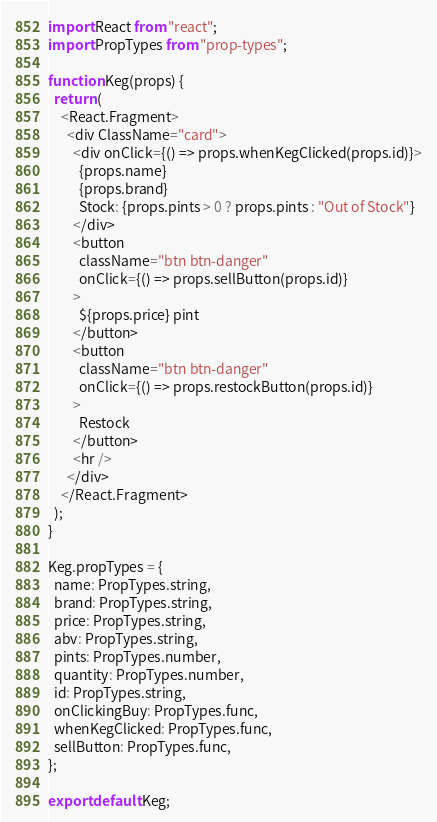Convert code to text. <code><loc_0><loc_0><loc_500><loc_500><_JavaScript_>import React from "react";
import PropTypes from "prop-types";

function Keg(props) {
  return (
    <React.Fragment>
      <div ClassName="card">
        <div onClick={() => props.whenKegClicked(props.id)}>
          {props.name}
          {props.brand}
          Stock: {props.pints > 0 ? props.pints : "Out of Stock"}
        </div>
        <button
          className="btn btn-danger"
          onClick={() => props.sellButton(props.id)}
        >
          ${props.price} pint
        </button>
        <button
          className="btn btn-danger"
          onClick={() => props.restockButton(props.id)}
        >
          Restock
        </button>
        <hr />
      </div>
    </React.Fragment>
  );
}

Keg.propTypes = {
  name: PropTypes.string,
  brand: PropTypes.string,
  price: PropTypes.string,
  abv: PropTypes.string,
  pints: PropTypes.number,
  quantity: PropTypes.number,
  id: PropTypes.string,
  onClickingBuy: PropTypes.func,
  whenKegClicked: PropTypes.func,
  sellButton: PropTypes.func,
};

export default Keg;
</code> 